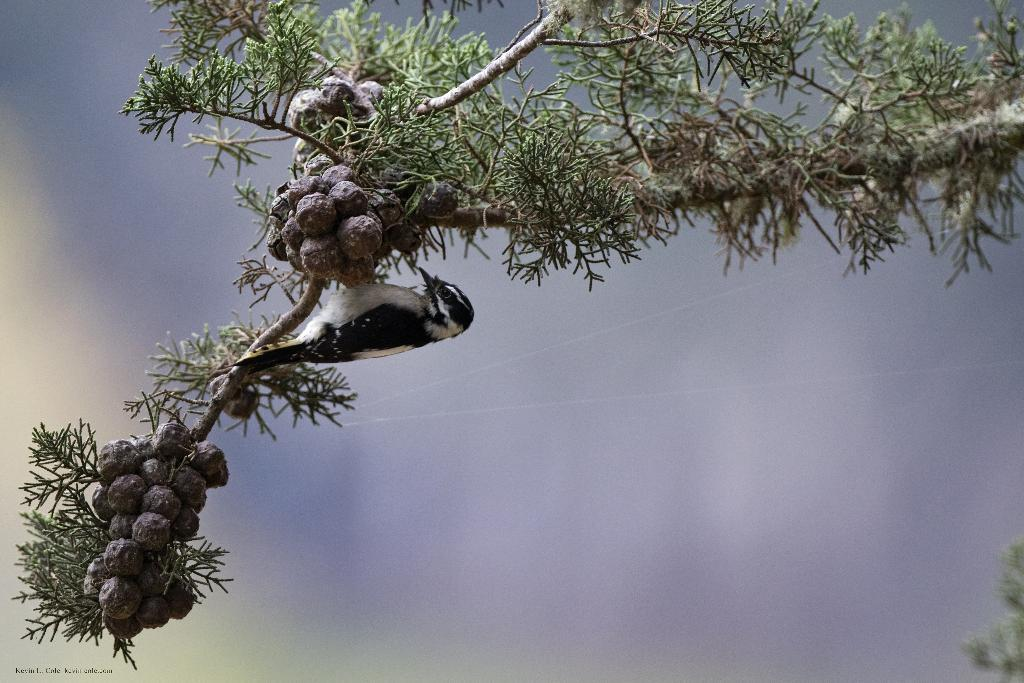What type of animal is in the image? There is a bird in the image. Where is the bird located? The bird is on a tree branch. Can you describe the position of the tree branch in the image? The tree branch is in the center of the image. What type of reward is the bird holding in the image? There is no reward present in the image; the bird is simply perched on a tree branch. 